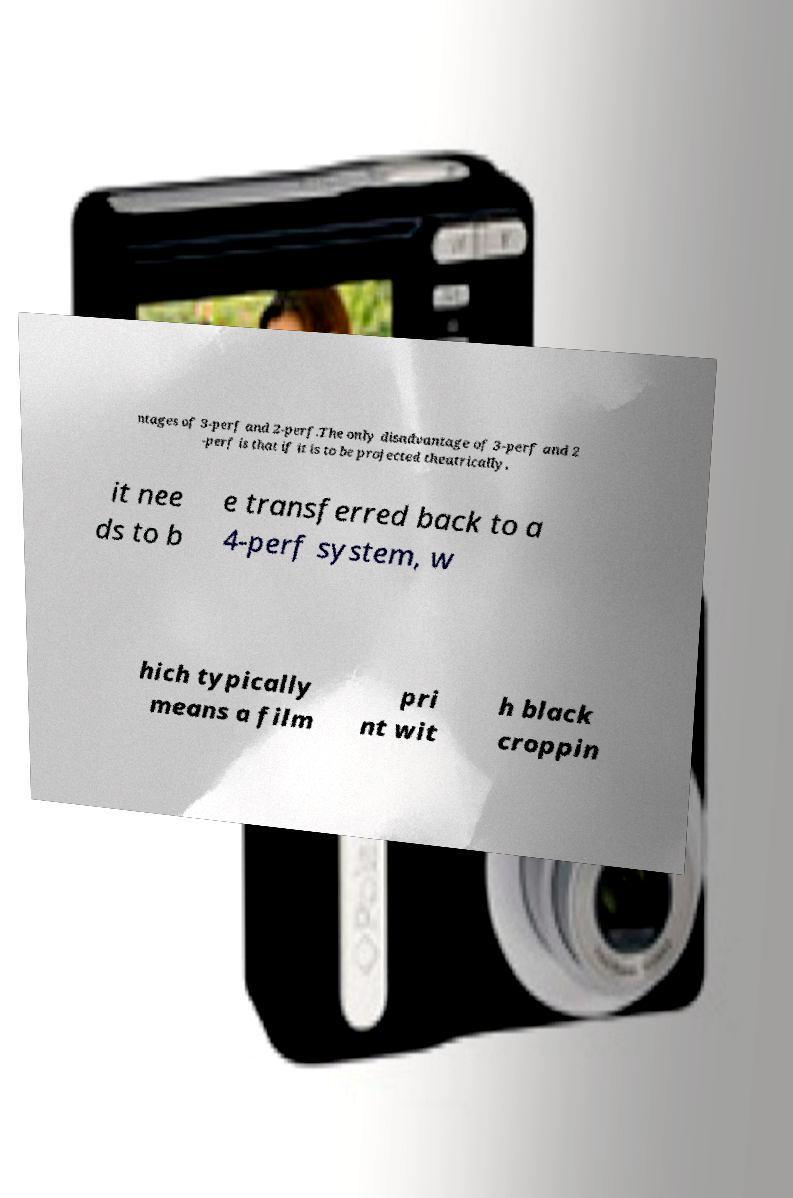Could you assist in decoding the text presented in this image and type it out clearly? ntages of 3-perf and 2-perf.The only disadvantage of 3-perf and 2 -perf is that if it is to be projected theatrically, it nee ds to b e transferred back to a 4-perf system, w hich typically means a film pri nt wit h black croppin 